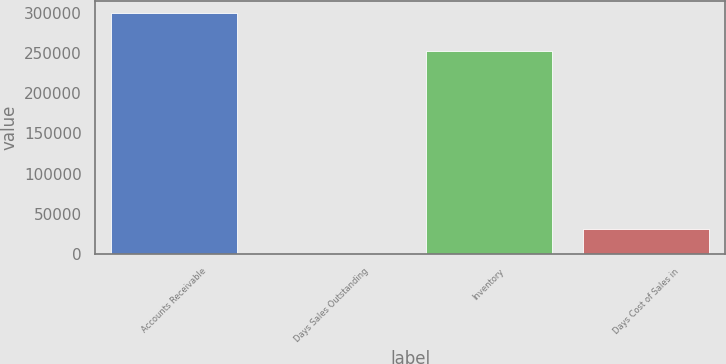Convert chart. <chart><loc_0><loc_0><loc_500><loc_500><bar_chart><fcel>Accounts Receivable<fcel>Days Sales Outstanding<fcel>Inventory<fcel>Days Cost of Sales in<nl><fcel>301036<fcel>48<fcel>253161<fcel>30146.8<nl></chart> 